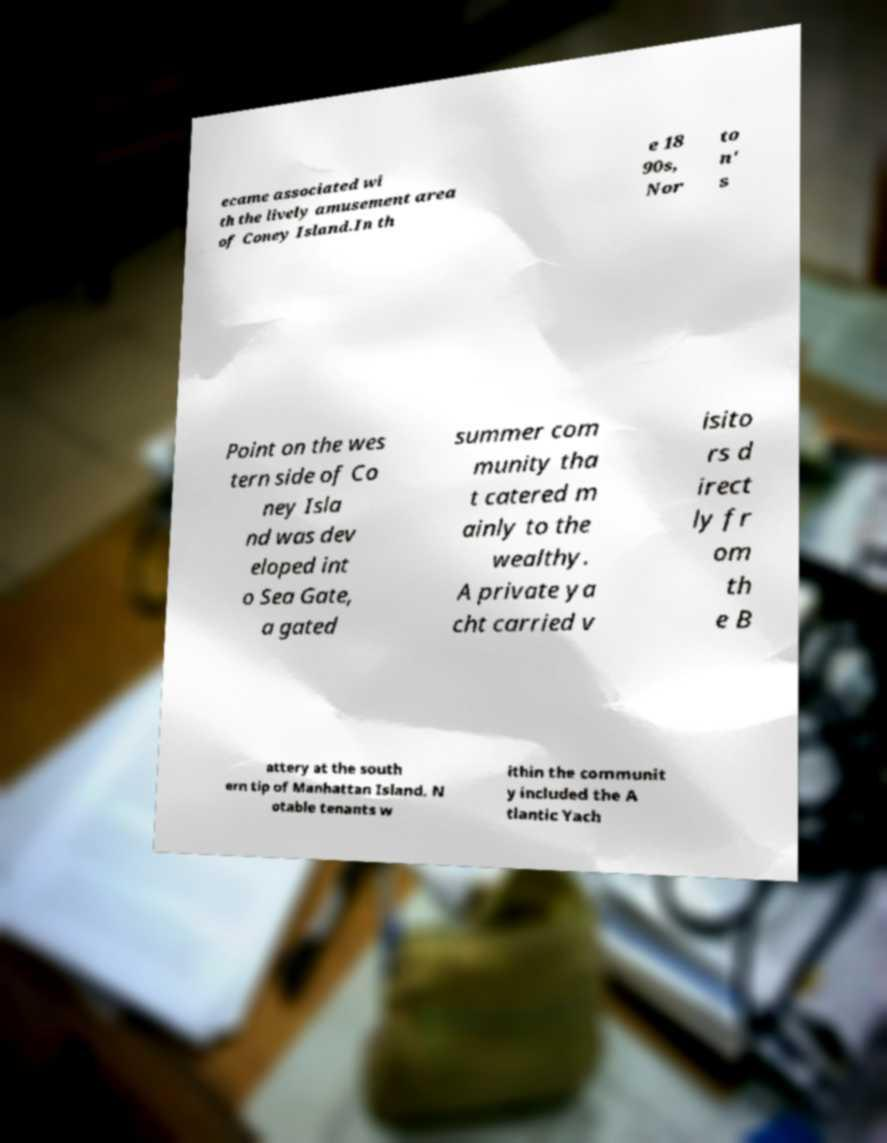There's text embedded in this image that I need extracted. Can you transcribe it verbatim? ecame associated wi th the lively amusement area of Coney Island.In th e 18 90s, Nor to n' s Point on the wes tern side of Co ney Isla nd was dev eloped int o Sea Gate, a gated summer com munity tha t catered m ainly to the wealthy. A private ya cht carried v isito rs d irect ly fr om th e B attery at the south ern tip of Manhattan Island. N otable tenants w ithin the communit y included the A tlantic Yach 